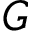<formula> <loc_0><loc_0><loc_500><loc_500>G</formula> 